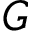<formula> <loc_0><loc_0><loc_500><loc_500>G</formula> 